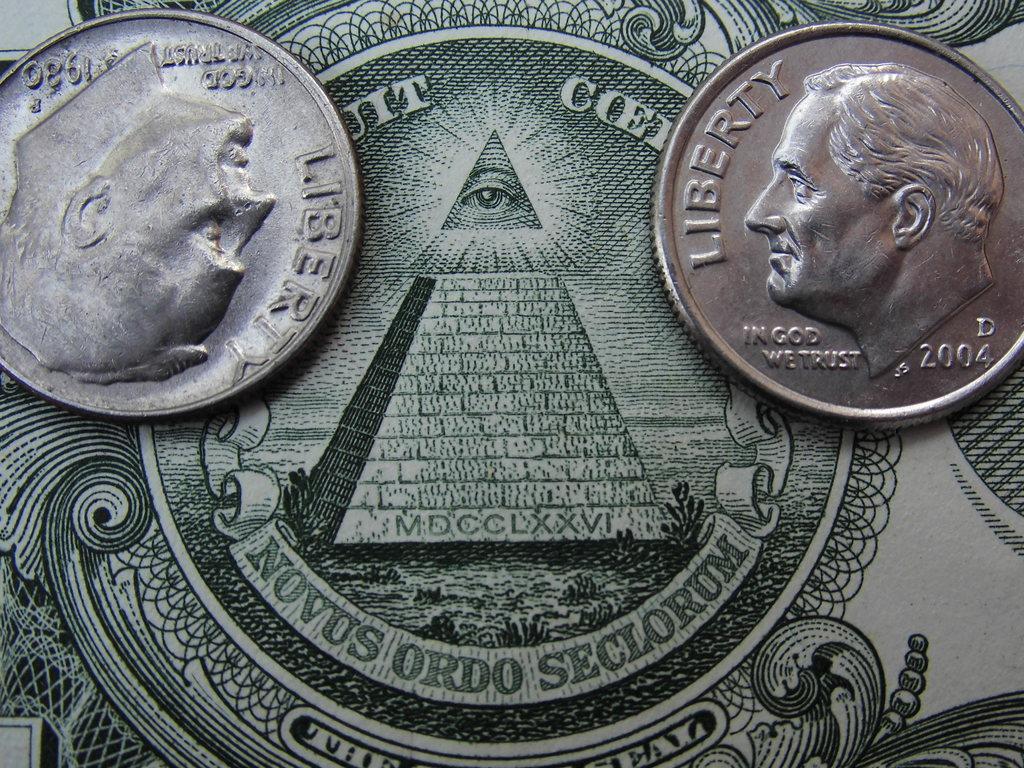What year was the coin on the right made?
Keep it short and to the point. 2004. What does it say on the base of the pyramid?
Make the answer very short. Mdcclxxvi. 